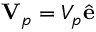<formula> <loc_0><loc_0><loc_500><loc_500>V _ { p } = V _ { p } \hat { e }</formula> 